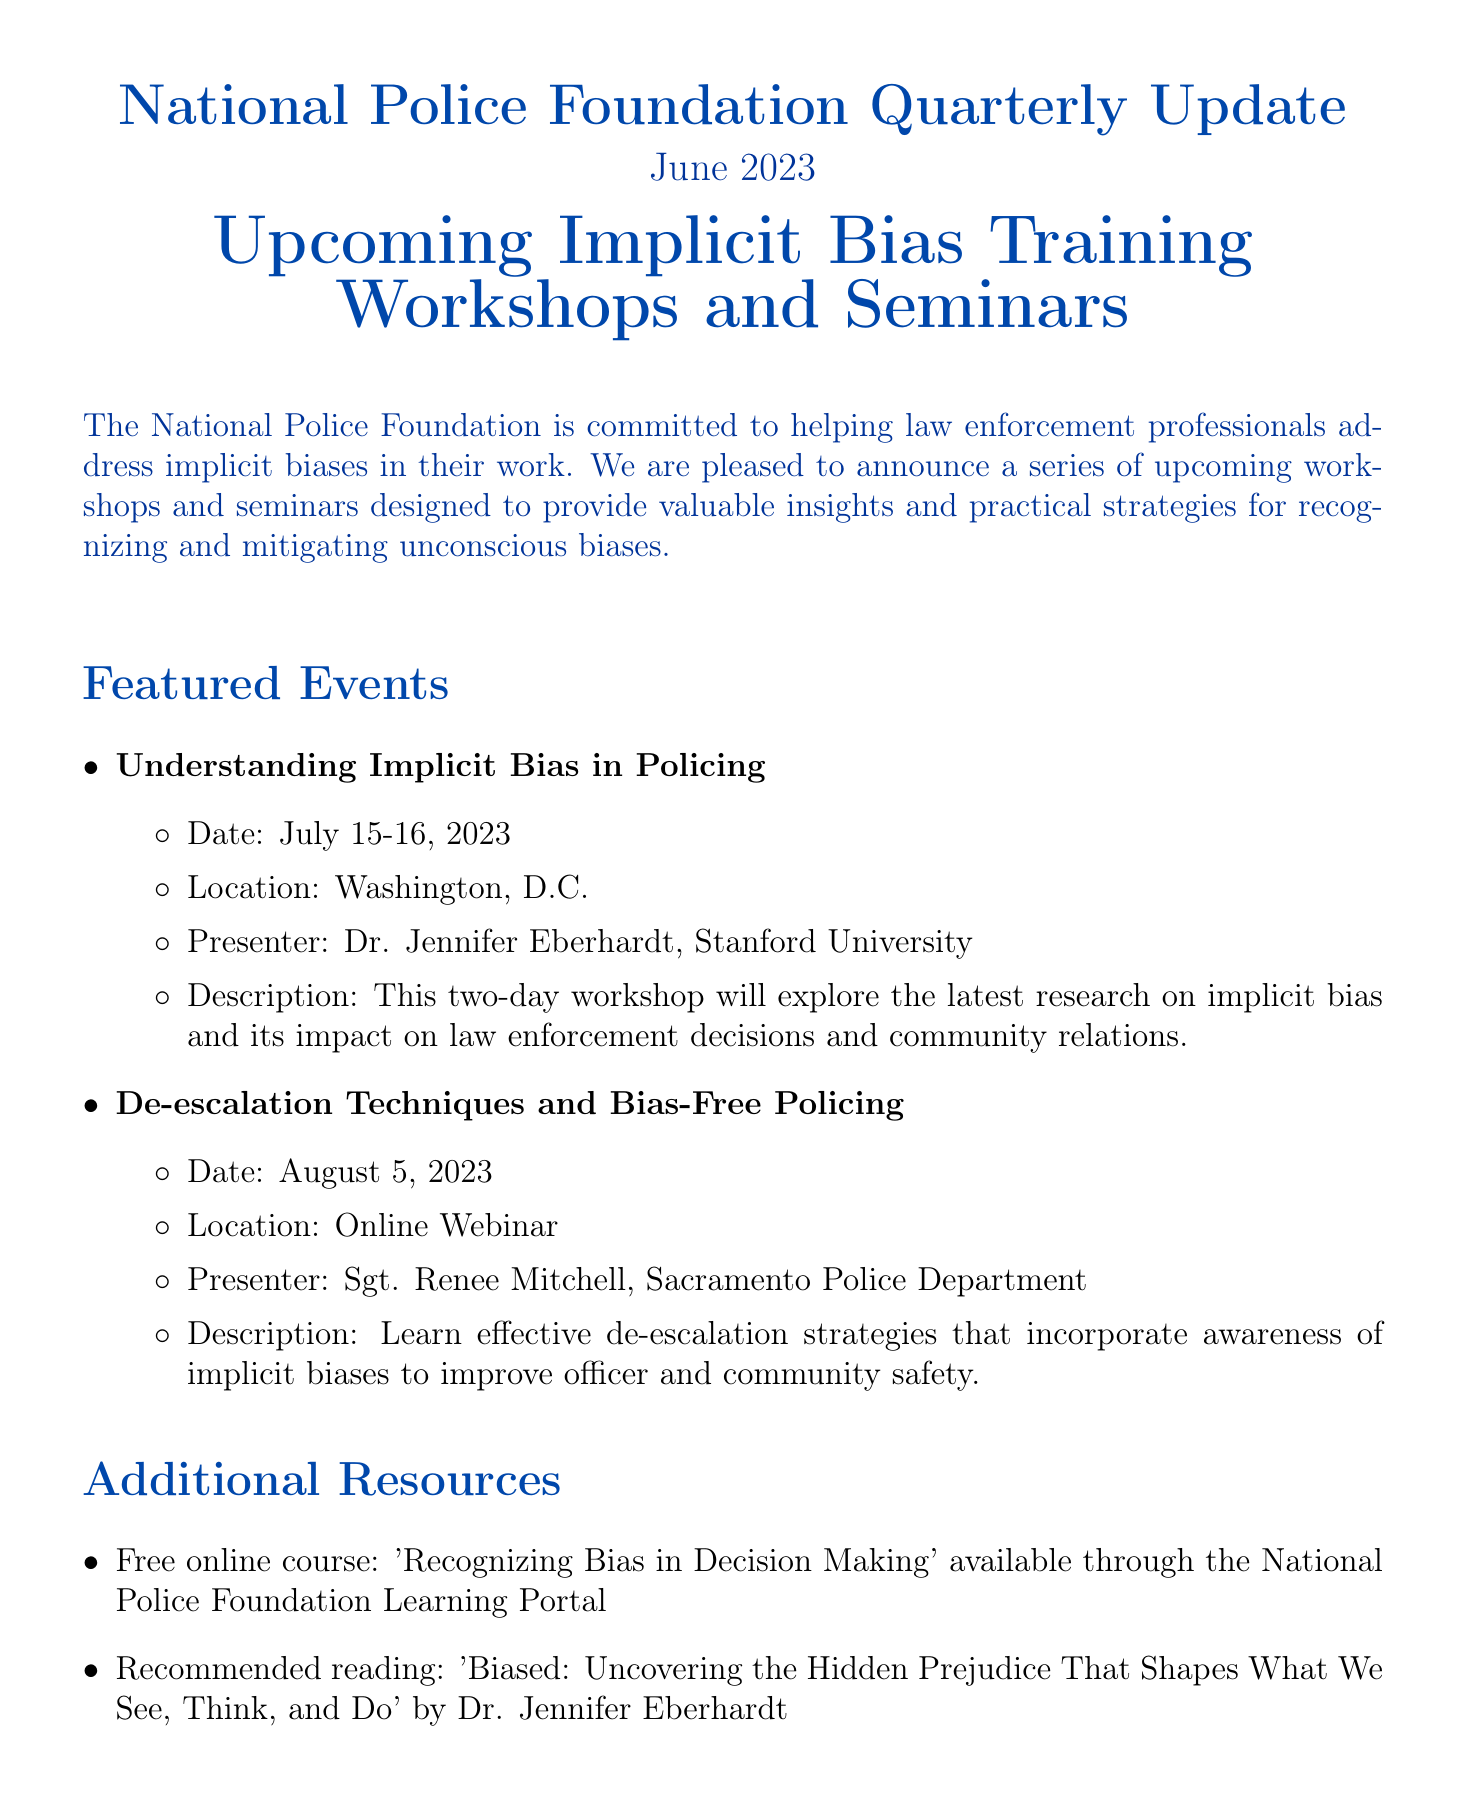What is the title of the newsletter? The title of the newsletter is presented prominently at the beginning of the document, indicating its focus.
Answer: National Police Foundation Quarterly Update What is the date of the first workshop? The date of the first workshop is mentioned in the featured events section of the document.
Answer: July 15-16, 2023 Who is the presenter for the de-escalation techniques workshop? The name of the presenter for this specific workshop is listed under the description of the event.
Answer: Sgt. Renee Mitchell What is the early bird registration deadline? The deadline for early bird registration is specified in the registration information section.
Answer: June 30, 2023 What location is the "Understanding Implicit Bias in Policing" workshop held? The location for the workshop is explicitly stated in the event's details.
Answer: Washington, D.C What type of course is offered for free? The document describes the type of resource available free of charge.
Answer: Online course Which book is recommended reading in the newsletter? The document includes a specific title as recommended reading for further insights.
Answer: Biased: Uncovering the Hidden Prejudice That Shapes What We See, Think, and Do In what format is the second workshop being conducted? The format of the second workshop, as described in the document, indicates how it is being delivered.
Answer: Online Webinar Who is presenting the first workshop? The presenter for the first event is identified in the details provided for that workshop.
Answer: Dr. Jennifer Eberhardt, Stanford University 